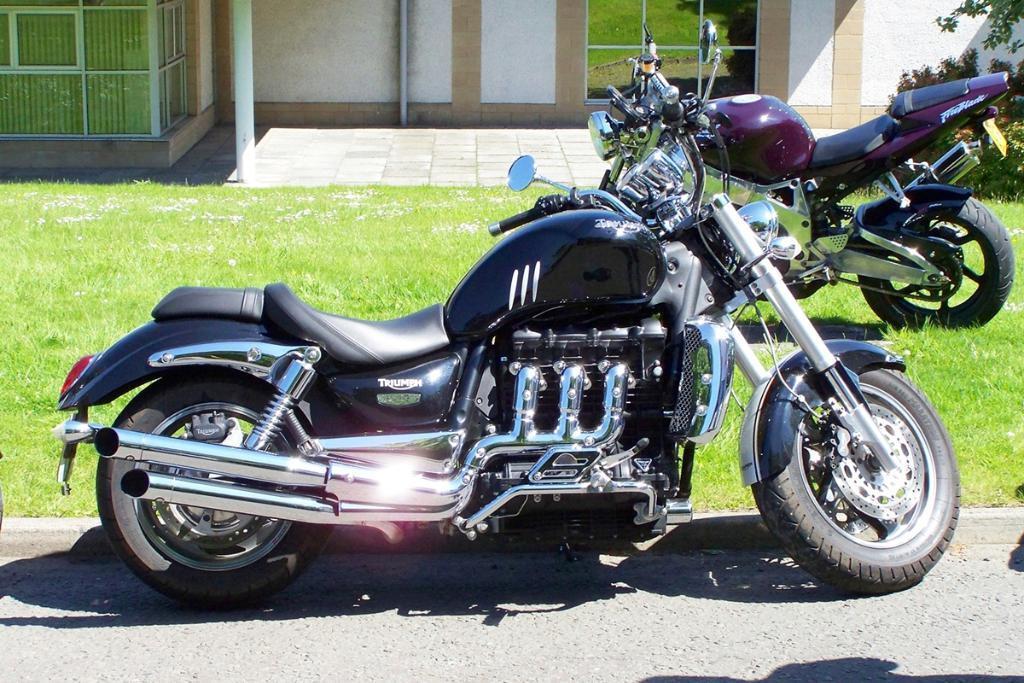Please provide a concise description of this image. In this picture I can observe two bikes parked on the land in the middle of the picture. I can observe some grass on the ground. In the background I can observe wall. 